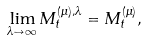Convert formula to latex. <formula><loc_0><loc_0><loc_500><loc_500>\lim _ { \lambda \to \infty } M ^ { ( \mu ) , \lambda } _ { t } = M ^ { ( \mu ) } _ { t } ,</formula> 